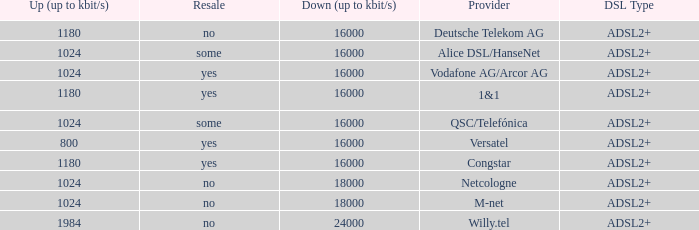Who are all of the telecom providers for which the upload rate is 1024 kbits and the resale category is yes? Vodafone AG/Arcor AG. 